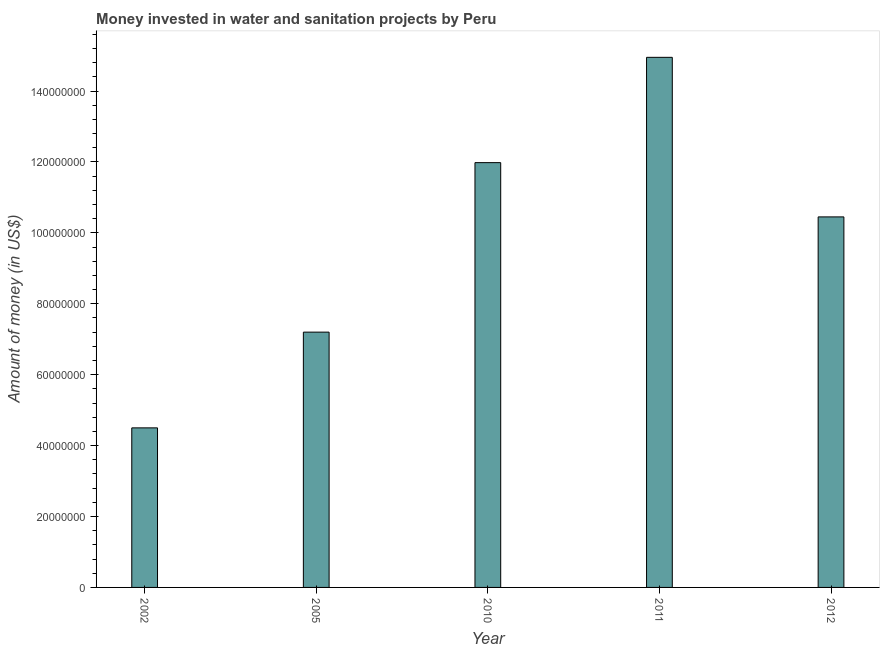What is the title of the graph?
Make the answer very short. Money invested in water and sanitation projects by Peru. What is the label or title of the X-axis?
Provide a succinct answer. Year. What is the label or title of the Y-axis?
Your response must be concise. Amount of money (in US$). What is the investment in 2002?
Your response must be concise. 4.50e+07. Across all years, what is the maximum investment?
Offer a terse response. 1.50e+08. Across all years, what is the minimum investment?
Give a very brief answer. 4.50e+07. In which year was the investment maximum?
Your answer should be very brief. 2011. What is the sum of the investment?
Offer a terse response. 4.91e+08. What is the difference between the investment in 2002 and 2010?
Your response must be concise. -7.48e+07. What is the average investment per year?
Your response must be concise. 9.82e+07. What is the median investment?
Your answer should be compact. 1.04e+08. What is the ratio of the investment in 2005 to that in 2010?
Ensure brevity in your answer.  0.6. Is the difference between the investment in 2002 and 2010 greater than the difference between any two years?
Ensure brevity in your answer.  No. What is the difference between the highest and the second highest investment?
Offer a terse response. 2.97e+07. Is the sum of the investment in 2002 and 2005 greater than the maximum investment across all years?
Provide a short and direct response. No. What is the difference between the highest and the lowest investment?
Make the answer very short. 1.04e+08. In how many years, is the investment greater than the average investment taken over all years?
Your answer should be very brief. 3. Are all the bars in the graph horizontal?
Your answer should be very brief. No. How many years are there in the graph?
Your response must be concise. 5. What is the Amount of money (in US$) of 2002?
Provide a short and direct response. 4.50e+07. What is the Amount of money (in US$) of 2005?
Keep it short and to the point. 7.20e+07. What is the Amount of money (in US$) in 2010?
Ensure brevity in your answer.  1.20e+08. What is the Amount of money (in US$) of 2011?
Give a very brief answer. 1.50e+08. What is the Amount of money (in US$) of 2012?
Your response must be concise. 1.04e+08. What is the difference between the Amount of money (in US$) in 2002 and 2005?
Provide a short and direct response. -2.70e+07. What is the difference between the Amount of money (in US$) in 2002 and 2010?
Provide a succinct answer. -7.48e+07. What is the difference between the Amount of money (in US$) in 2002 and 2011?
Keep it short and to the point. -1.04e+08. What is the difference between the Amount of money (in US$) in 2002 and 2012?
Your response must be concise. -5.95e+07. What is the difference between the Amount of money (in US$) in 2005 and 2010?
Give a very brief answer. -4.78e+07. What is the difference between the Amount of money (in US$) in 2005 and 2011?
Give a very brief answer. -7.75e+07. What is the difference between the Amount of money (in US$) in 2005 and 2012?
Ensure brevity in your answer.  -3.25e+07. What is the difference between the Amount of money (in US$) in 2010 and 2011?
Give a very brief answer. -2.97e+07. What is the difference between the Amount of money (in US$) in 2010 and 2012?
Make the answer very short. 1.53e+07. What is the difference between the Amount of money (in US$) in 2011 and 2012?
Your response must be concise. 4.50e+07. What is the ratio of the Amount of money (in US$) in 2002 to that in 2010?
Your response must be concise. 0.38. What is the ratio of the Amount of money (in US$) in 2002 to that in 2011?
Ensure brevity in your answer.  0.3. What is the ratio of the Amount of money (in US$) in 2002 to that in 2012?
Provide a short and direct response. 0.43. What is the ratio of the Amount of money (in US$) in 2005 to that in 2010?
Provide a succinct answer. 0.6. What is the ratio of the Amount of money (in US$) in 2005 to that in 2011?
Make the answer very short. 0.48. What is the ratio of the Amount of money (in US$) in 2005 to that in 2012?
Your answer should be compact. 0.69. What is the ratio of the Amount of money (in US$) in 2010 to that in 2011?
Give a very brief answer. 0.8. What is the ratio of the Amount of money (in US$) in 2010 to that in 2012?
Make the answer very short. 1.15. What is the ratio of the Amount of money (in US$) in 2011 to that in 2012?
Your answer should be compact. 1.43. 